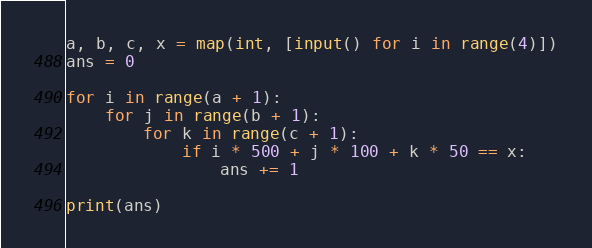<code> <loc_0><loc_0><loc_500><loc_500><_Python_>a, b, c, x = map(int, [input() for i in range(4)])
ans = 0

for i in range(a + 1):
    for j in range(b + 1):
        for k in range(c + 1):
            if i * 500 + j * 100 + k * 50 == x:
                ans += 1

print(ans)
</code> 